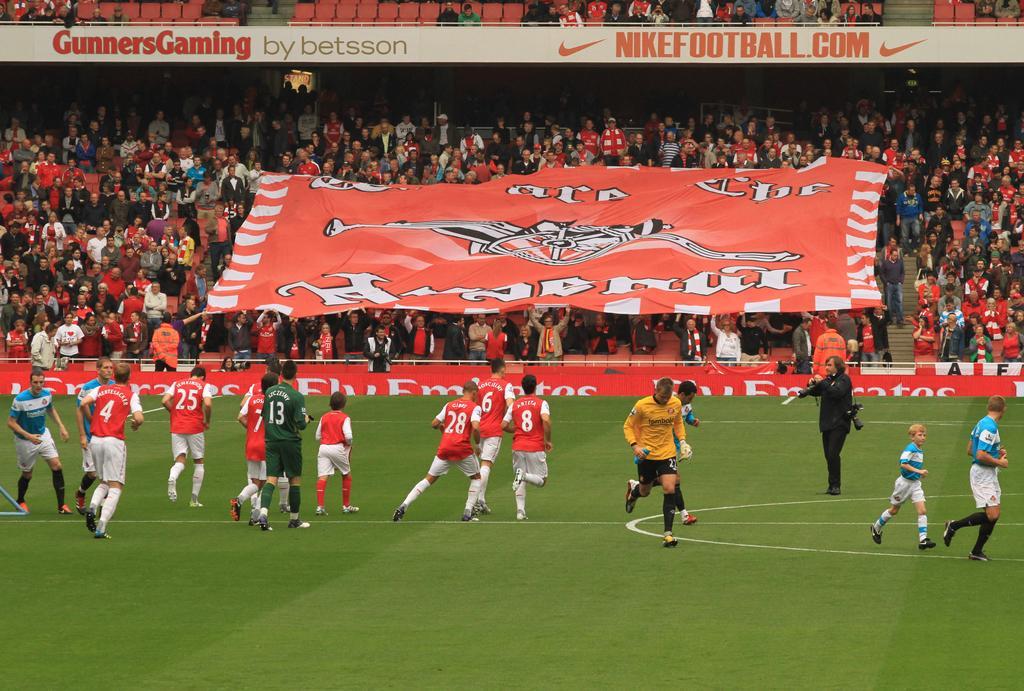Can you describe this image briefly? In this picture we can see a man holding a camera with his hands, some people are on the ground and in the background we can see a group of people, banner, some objects. 